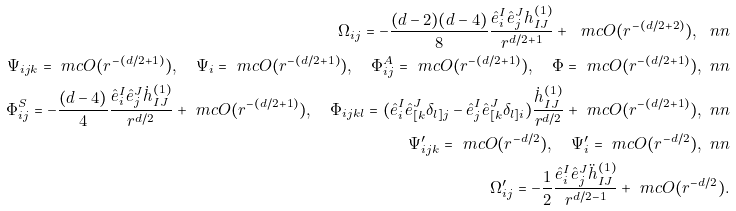Convert formula to latex. <formula><loc_0><loc_0><loc_500><loc_500>\Omega _ { i j } = - \frac { ( d - 2 ) ( d - 4 ) } { 8 } \frac { \hat { e } ^ { I } _ { i } \hat { e } ^ { J } _ { j } h ^ { ( 1 ) } _ { I J } } { r ^ { d / 2 + 1 } } + \ m c O ( r ^ { - ( d / 2 + 2 ) } ) , \ n n \\ \Psi _ { i j k } = \ m c O ( r ^ { - ( d / 2 + 1 ) } ) , \quad \Psi _ { i } = \ m c O ( r ^ { - ( d / 2 + 1 ) } ) , \quad \Phi ^ { A } _ { i j } = \ m c O ( r ^ { - ( d / 2 + 1 ) } ) , \quad \Phi = \ m c O ( r ^ { - ( d / 2 + 1 ) } ) , \ n n \\ \Phi ^ { S } _ { i j } = - \frac { ( d - 4 ) } { 4 } \frac { \hat { e } ^ { I } _ { i } \hat { e } ^ { J } _ { j } \dot { h } ^ { ( 1 ) } _ { I J } } { r ^ { d / 2 } } + \ m c O ( r ^ { - ( d / 2 + 1 ) } ) , \quad \Phi _ { i j k l } = ( \hat { e } _ { i } ^ { I } \hat { e } ^ { J } _ { [ k } \delta _ { l ] j } - \hat { e } _ { j } ^ { I } \hat { e } ^ { J } _ { [ k } \delta _ { l ] i } ) \frac { \dot { h } ^ { ( 1 ) } _ { I J } } { r ^ { d / 2 } } + \ m c O ( r ^ { - ( d / 2 + 1 ) } ) , \ n n \\ \Psi ^ { \prime } _ { i j k } = \ m c O ( r ^ { - d / 2 } ) , \quad \Psi ^ { \prime } _ { i } = \ m c O ( r ^ { - d / 2 } ) , \ n n \\ \Omega ^ { \prime } _ { i j } = - \frac { 1 } { 2 } \frac { \hat { e } _ { i } ^ { I } \hat { e } _ { j } ^ { J } \ddot { h } ^ { ( 1 ) } _ { I J } } { r ^ { d / 2 - 1 } } + \ m c O ( r ^ { - d / 2 } ) .</formula> 